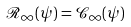<formula> <loc_0><loc_0><loc_500><loc_500>\mathcal { R } _ { \infty } ( \psi ) = \mathcal { C } _ { \infty } ( \psi )</formula> 